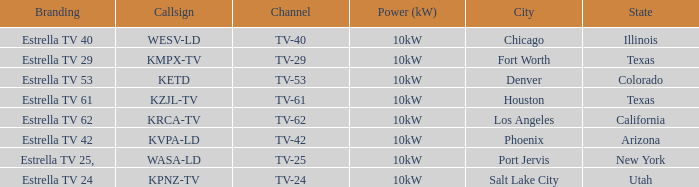List the branding name for channel tv-62. Estrella TV 62. 